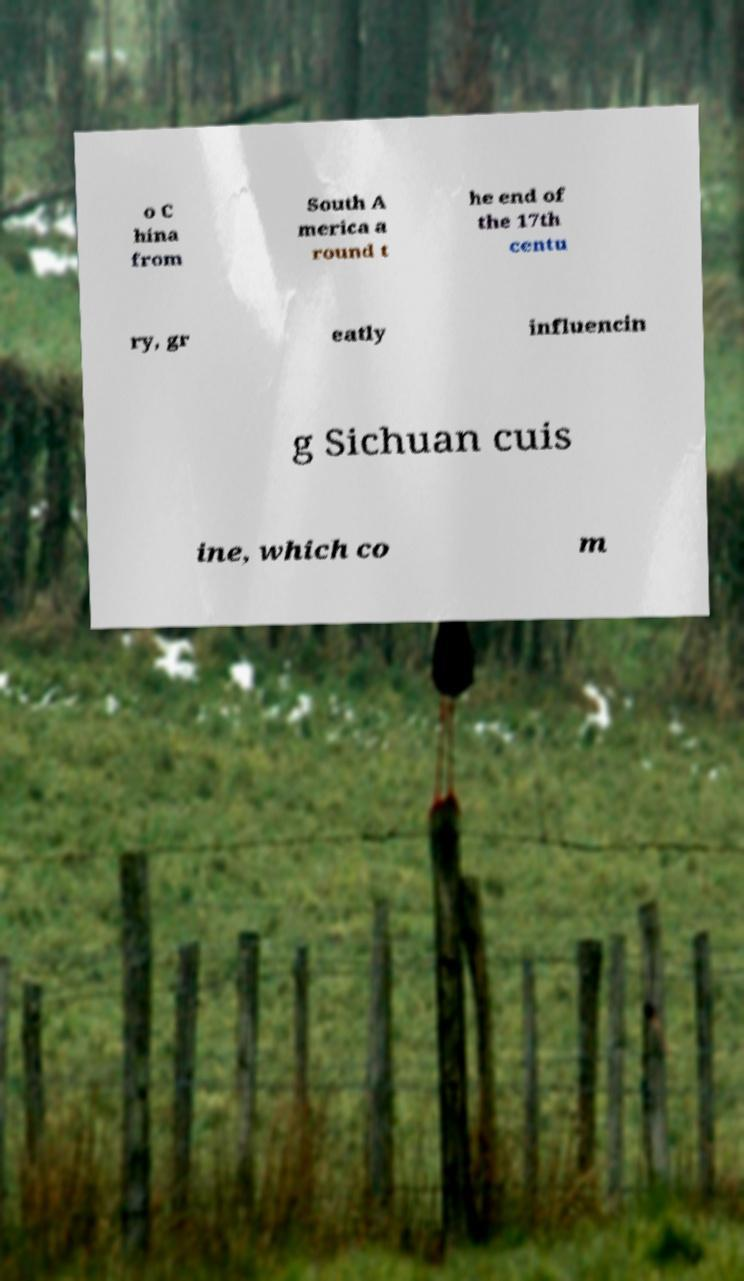Could you extract and type out the text from this image? o C hina from South A merica a round t he end of the 17th centu ry, gr eatly influencin g Sichuan cuis ine, which co m 